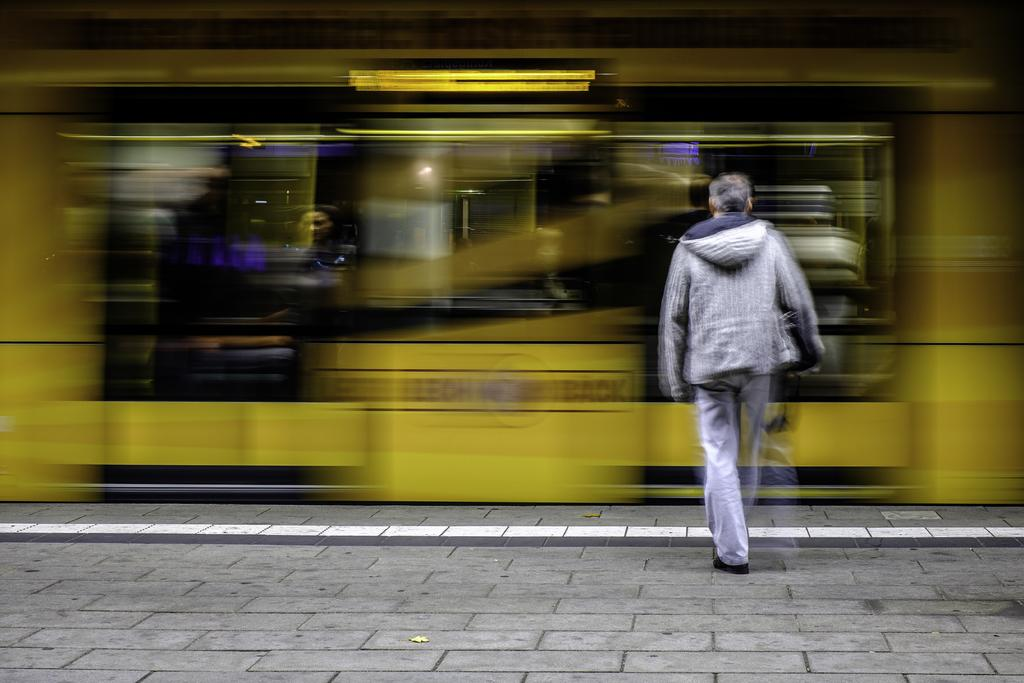Who is present in the image? There is a man in the image. Where is the man located in the image? The man is on the right side of the image. Can you describe the background of the image? The background of the image is blurred. What type of hen is the man learning to care for in the image? There is no hen present in the image, and the man is not shown learning to care for any animals. 